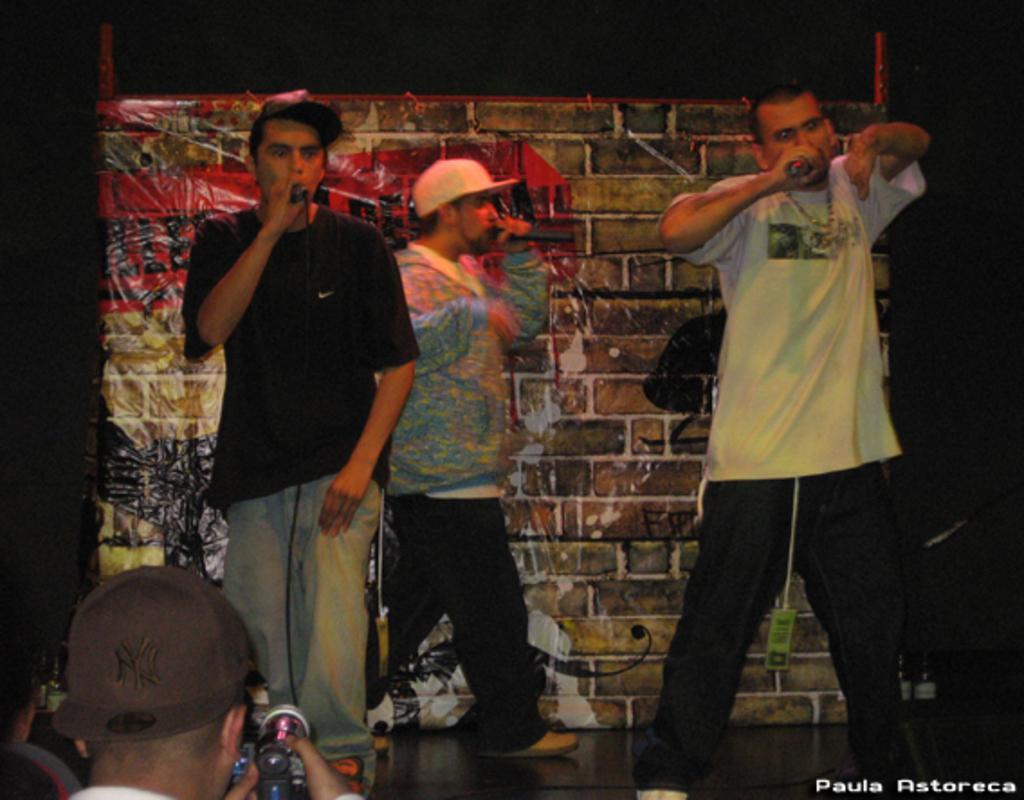Could you give a brief overview of what you see in this image? In the foreground of this image, there are three men standing holding mics. At the bottom, there is a man shooting with a camera. In the background, there is a banner wall in the dark. 